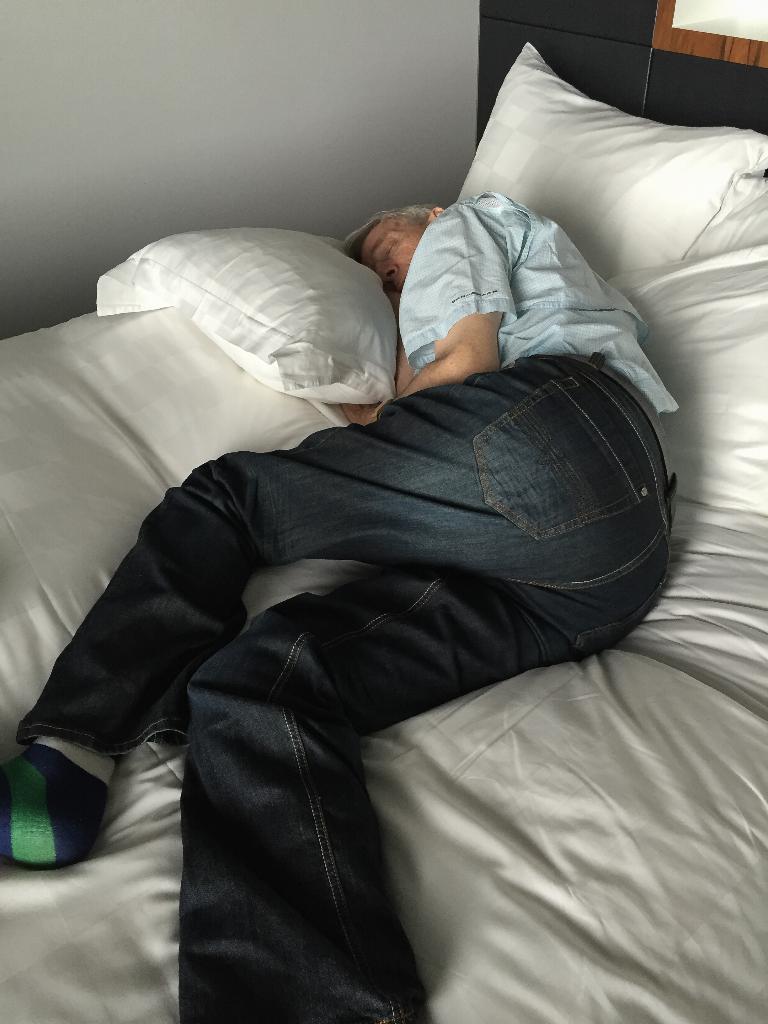Could you give a brief overview of what you see in this image? In this picture we can see man sleeping on bed with pillows on it and in background we can see wall. 